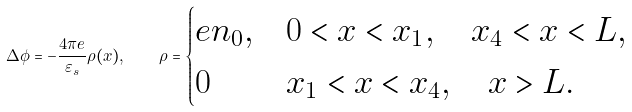<formula> <loc_0><loc_0><loc_500><loc_500>\Delta \phi = - \frac { 4 \pi e } { \varepsilon _ { s } } \rho ( x ) , \quad \rho = \begin{cases} e n _ { 0 } , & 0 < x < x _ { 1 } , \quad x _ { 4 } < x < L , \\ 0 & x _ { 1 } < x < x _ { 4 } , \quad x > L . \end{cases}</formula> 